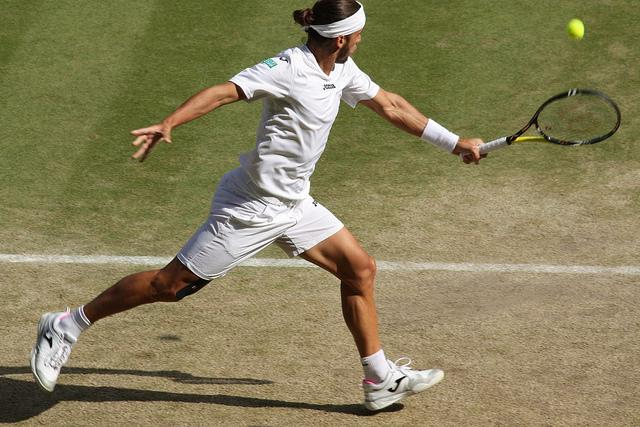What is in the man's hand?

Choices:
A) baseball bat
B) basketball
C) egg
D) tennis racquet tennis racquet 